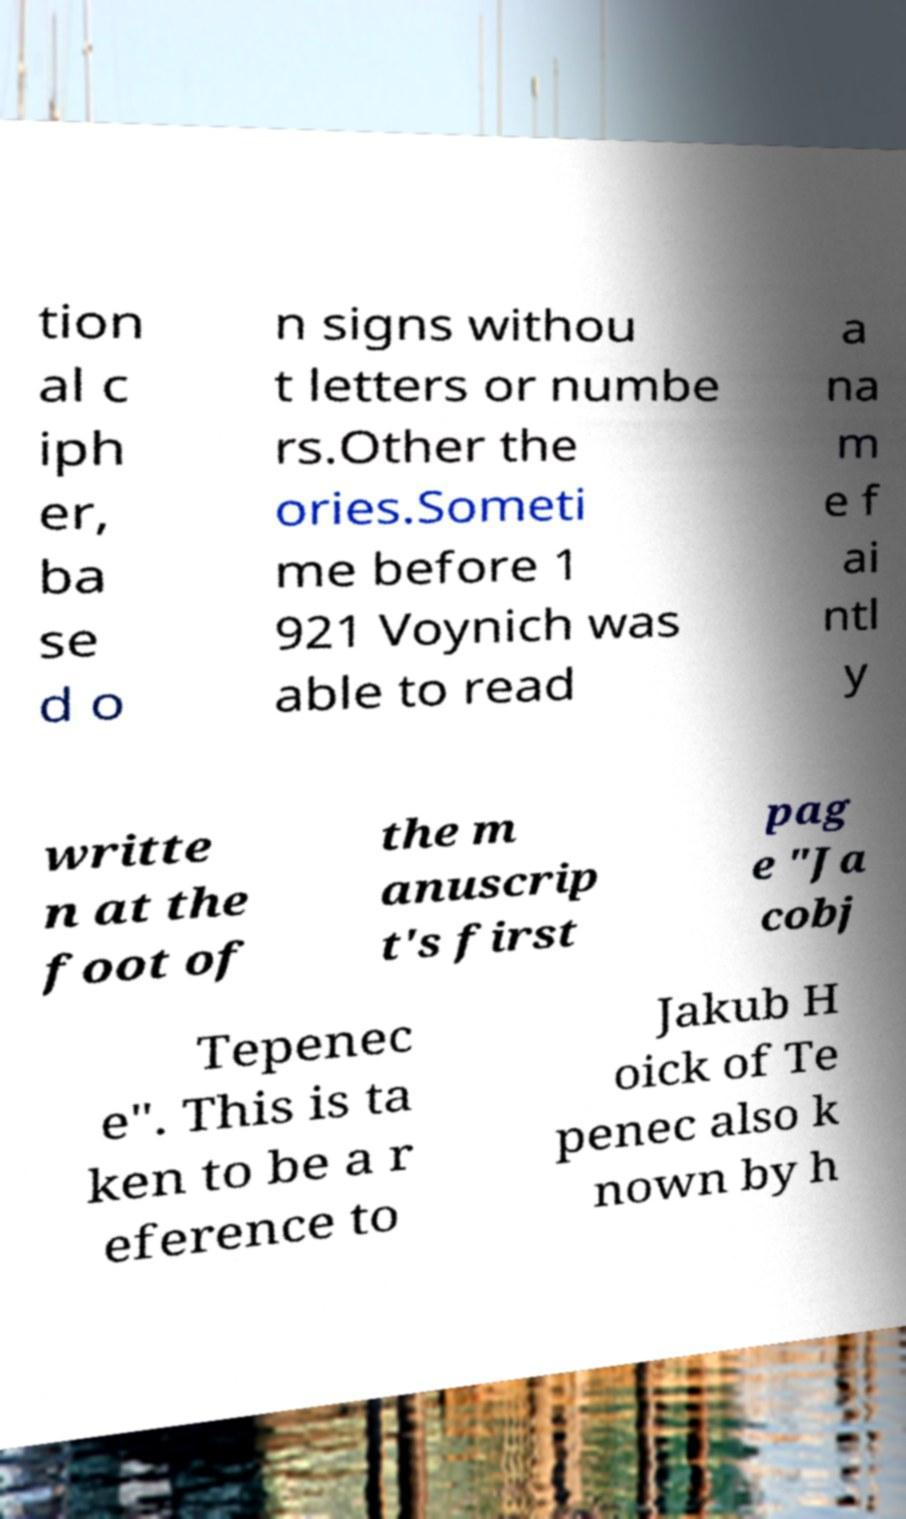I need the written content from this picture converted into text. Can you do that? tion al c iph er, ba se d o n signs withou t letters or numbe rs.Other the ories.Someti me before 1 921 Voynich was able to read a na m e f ai ntl y writte n at the foot of the m anuscrip t's first pag e "Ja cobj Tepenec e". This is ta ken to be a r eference to Jakub H oick of Te penec also k nown by h 